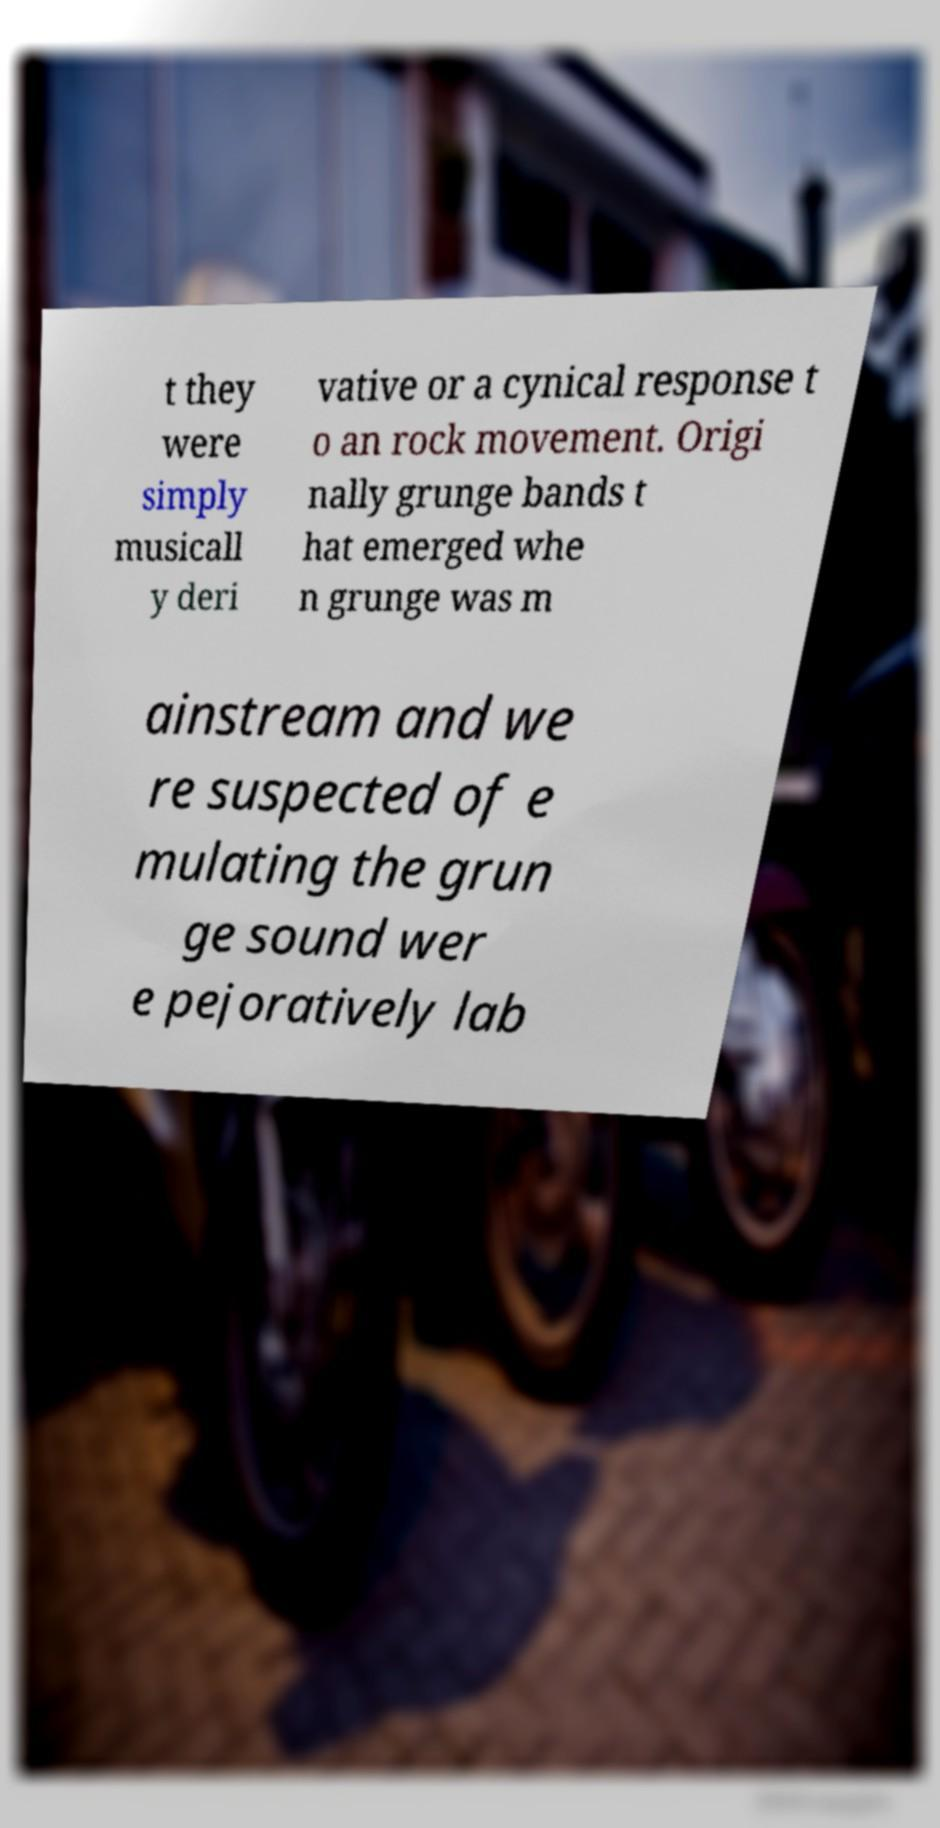Please read and relay the text visible in this image. What does it say? t they were simply musicall y deri vative or a cynical response t o an rock movement. Origi nally grunge bands t hat emerged whe n grunge was m ainstream and we re suspected of e mulating the grun ge sound wer e pejoratively lab 